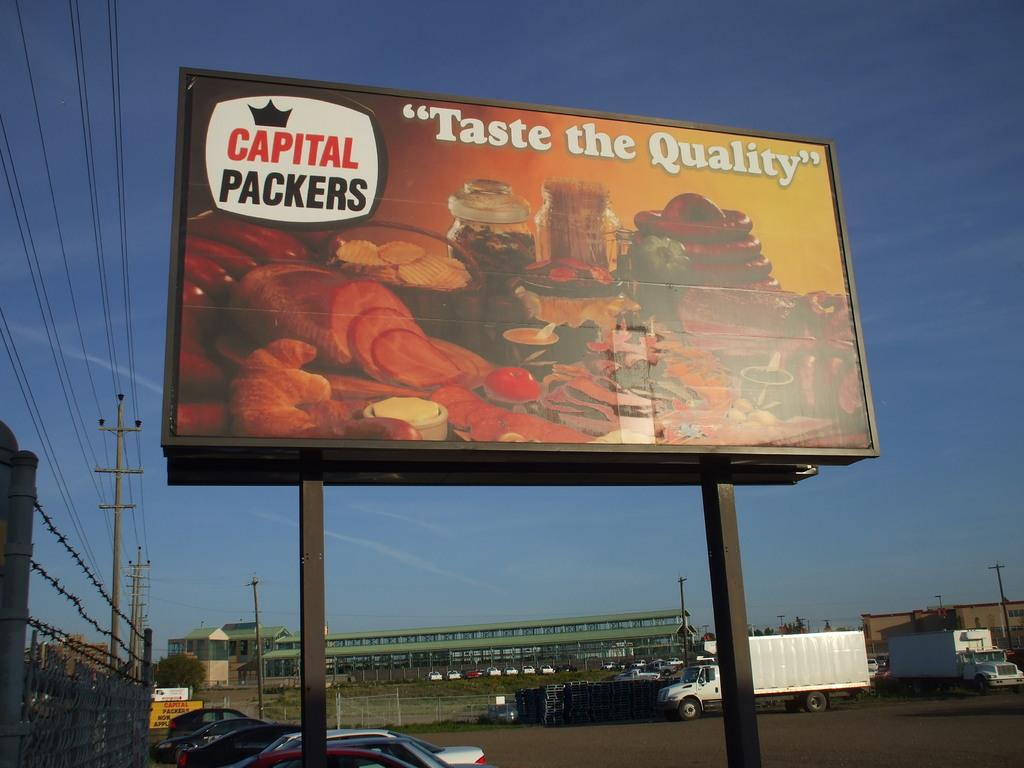<image>
Share a concise interpretation of the image provided. A large billboard advertising the quailty of Capital Packers foods. 